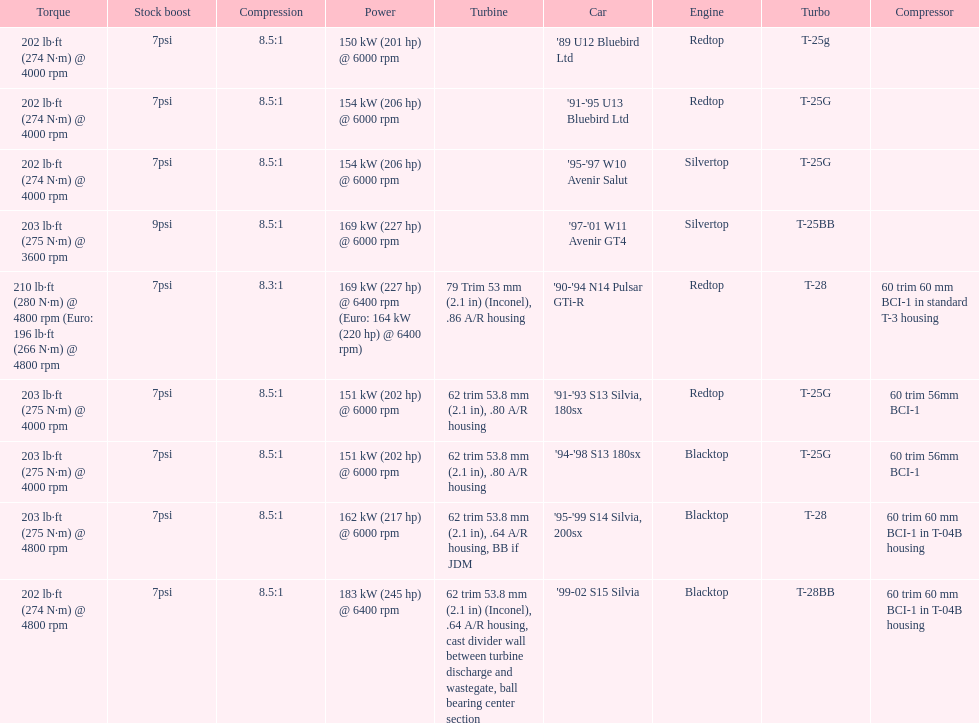Which engine(s) has the least amount of power? Redtop. Help me parse the entirety of this table. {'header': ['Torque', 'Stock boost', 'Compression', 'Power', 'Turbine', 'Car', 'Engine', 'Turbo', 'Compressor'], 'rows': [['202\xa0lb·ft (274\xa0N·m) @ 4000 rpm', '7psi', '8.5:1', '150\xa0kW (201\xa0hp) @ 6000 rpm', '', "'89 U12 Bluebird Ltd", 'Redtop', 'T-25g', ''], ['202\xa0lb·ft (274\xa0N·m) @ 4000 rpm', '7psi', '8.5:1', '154\xa0kW (206\xa0hp) @ 6000 rpm', '', "'91-'95 U13 Bluebird Ltd", 'Redtop', 'T-25G', ''], ['202\xa0lb·ft (274\xa0N·m) @ 4000 rpm', '7psi', '8.5:1', '154\xa0kW (206\xa0hp) @ 6000 rpm', '', "'95-'97 W10 Avenir Salut", 'Silvertop', 'T-25G', ''], ['203\xa0lb·ft (275\xa0N·m) @ 3600 rpm', '9psi', '8.5:1', '169\xa0kW (227\xa0hp) @ 6000 rpm', '', "'97-'01 W11 Avenir GT4", 'Silvertop', 'T-25BB', ''], ['210\xa0lb·ft (280\xa0N·m) @ 4800 rpm (Euro: 196\xa0lb·ft (266\xa0N·m) @ 4800 rpm', '7psi', '8.3:1', '169\xa0kW (227\xa0hp) @ 6400 rpm (Euro: 164\xa0kW (220\xa0hp) @ 6400 rpm)', '79 Trim 53\xa0mm (2.1\xa0in) (Inconel), .86 A/R housing', "'90-'94 N14 Pulsar GTi-R", 'Redtop', 'T-28', '60 trim 60\xa0mm BCI-1 in standard T-3 housing'], ['203\xa0lb·ft (275\xa0N·m) @ 4000 rpm', '7psi', '8.5:1', '151\xa0kW (202\xa0hp) @ 6000 rpm', '62 trim 53.8\xa0mm (2.1\xa0in), .80 A/R housing', "'91-'93 S13 Silvia, 180sx", 'Redtop', 'T-25G', '60 trim 56mm BCI-1'], ['203\xa0lb·ft (275\xa0N·m) @ 4000 rpm', '7psi', '8.5:1', '151\xa0kW (202\xa0hp) @ 6000 rpm', '62 trim 53.8\xa0mm (2.1\xa0in), .80 A/R housing', "'94-'98 S13 180sx", 'Blacktop', 'T-25G', '60 trim 56mm BCI-1'], ['203\xa0lb·ft (275\xa0N·m) @ 4800 rpm', '7psi', '8.5:1', '162\xa0kW (217\xa0hp) @ 6000 rpm', '62 trim 53.8\xa0mm (2.1\xa0in), .64 A/R housing, BB if JDM', "'95-'99 S14 Silvia, 200sx", 'Blacktop', 'T-28', '60 trim 60\xa0mm BCI-1 in T-04B housing'], ['202\xa0lb·ft (274\xa0N·m) @ 4800 rpm', '7psi', '8.5:1', '183\xa0kW (245\xa0hp) @ 6400 rpm', '62 trim 53.8\xa0mm (2.1\xa0in) (Inconel), .64 A/R housing, cast divider wall between turbine discharge and wastegate, ball bearing center section', "'99-02 S15 Silvia", 'Blacktop', 'T-28BB', '60 trim 60\xa0mm BCI-1 in T-04B housing']]} 